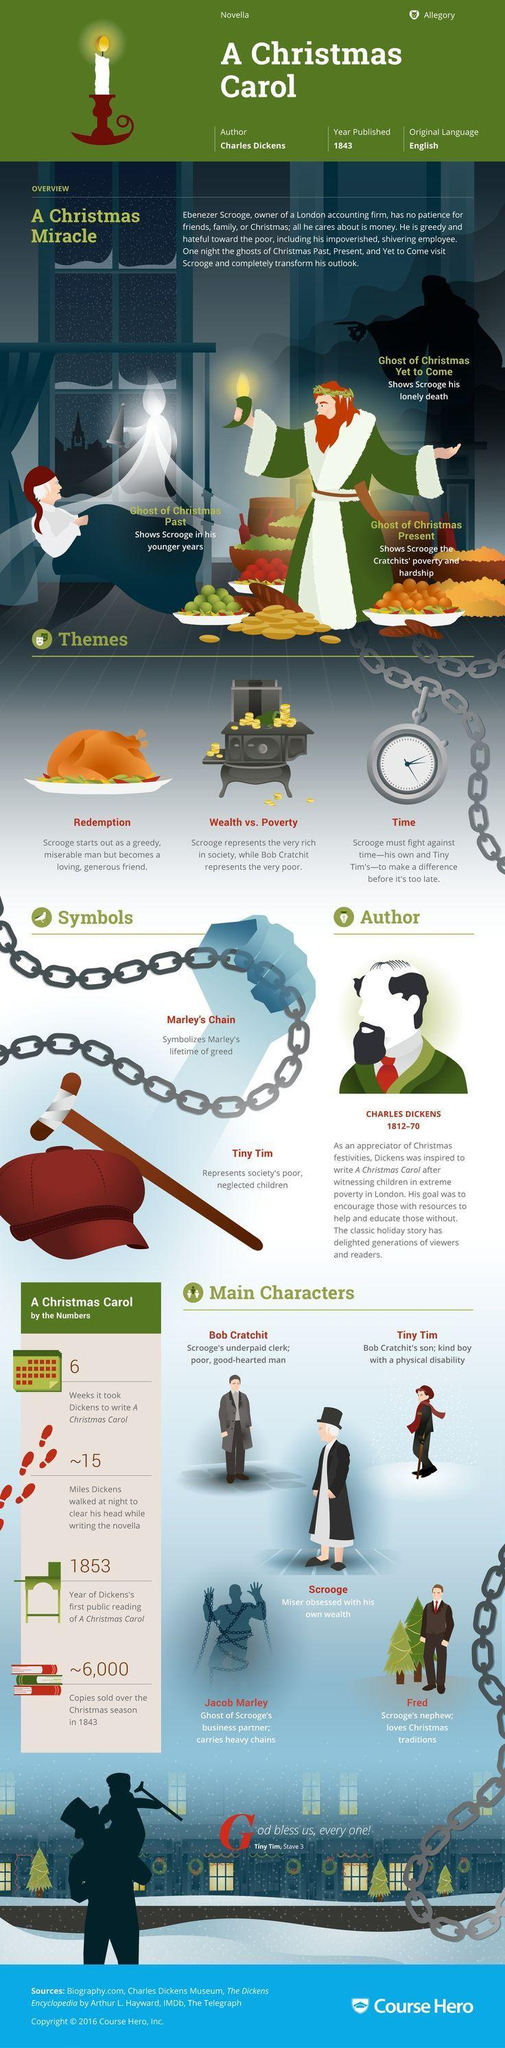How many different themes are listed for Christmas carol?
Answer the question with a short phrase. 3 When did the author of "A Christmas carol" was born? 1812 What made Dickens write a novel based on Christmas? after witnessing children in extreme poverty in London Which character in the novel is having big chains? Jacob Marley What is the role of the main character in the novel "A Christmas Carol"? Miser obsessed with his own wealth Which are the two metaphors used in "A Christmas carol"? Marley's Chain, Tiny Tim What is the second metaphor used in the novel "A Christmas carol"? Tiny Tim 